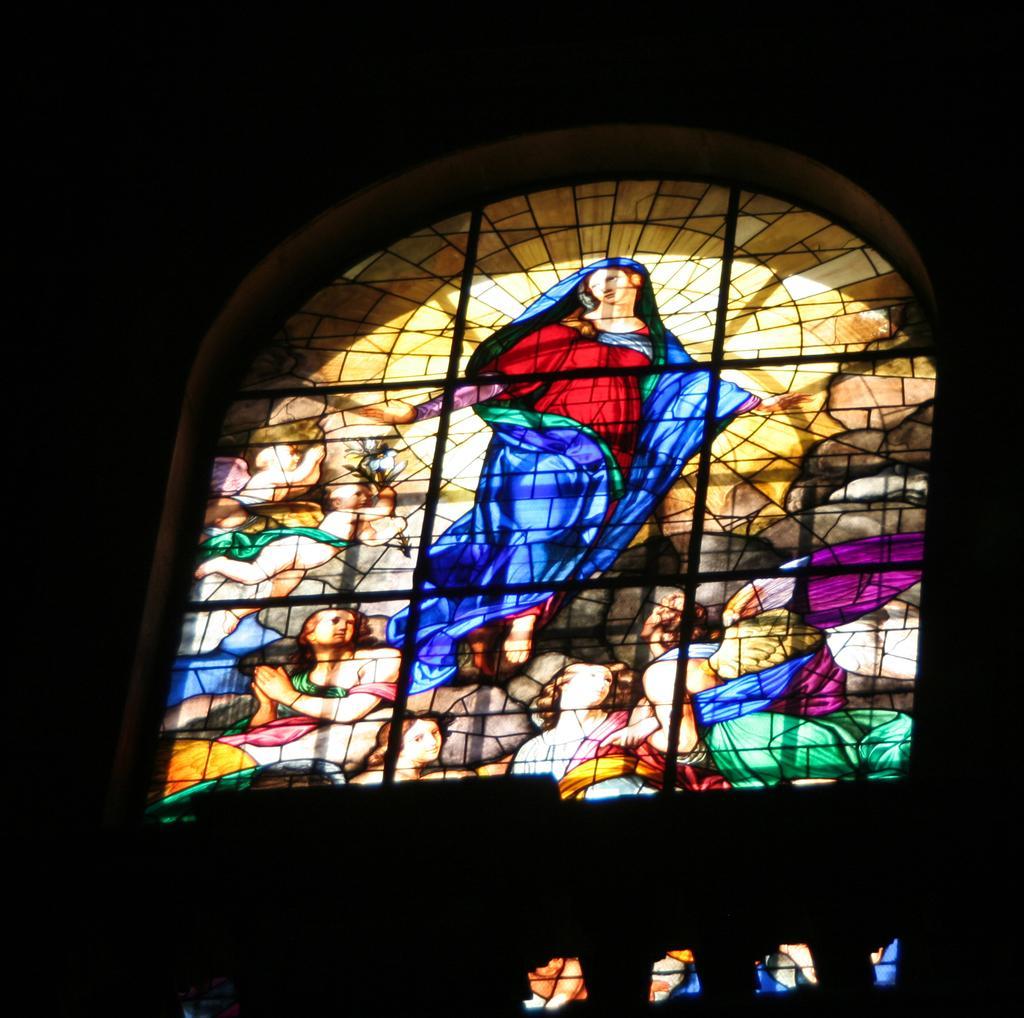In one or two sentences, can you explain what this image depicts? In the picture there is a window and there are some paintings on the window. 